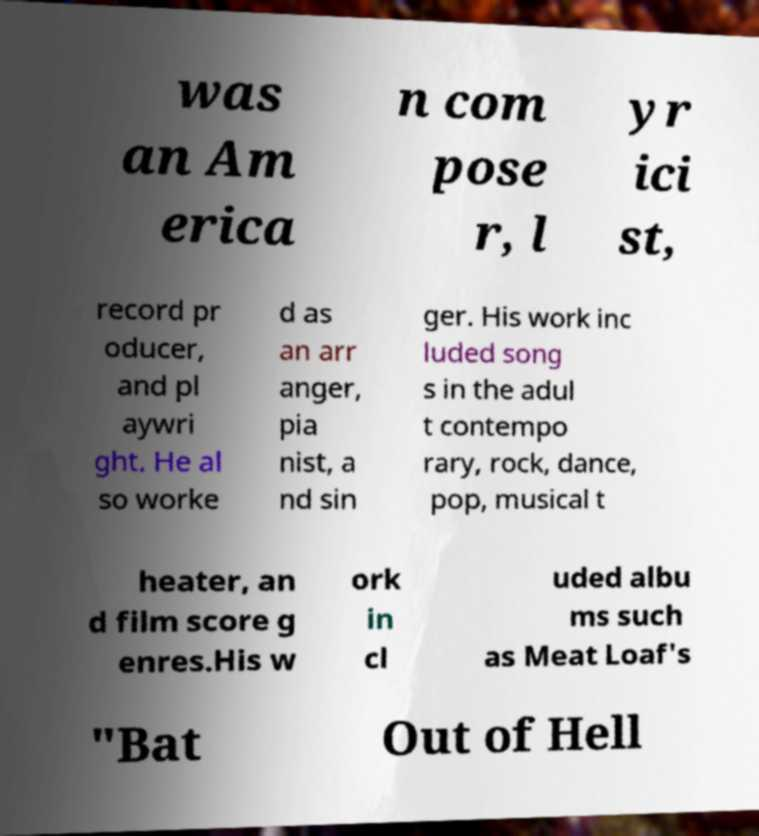Please identify and transcribe the text found in this image. was an Am erica n com pose r, l yr ici st, record pr oducer, and pl aywri ght. He al so worke d as an arr anger, pia nist, a nd sin ger. His work inc luded song s in the adul t contempo rary, rock, dance, pop, musical t heater, an d film score g enres.His w ork in cl uded albu ms such as Meat Loaf's "Bat Out of Hell 